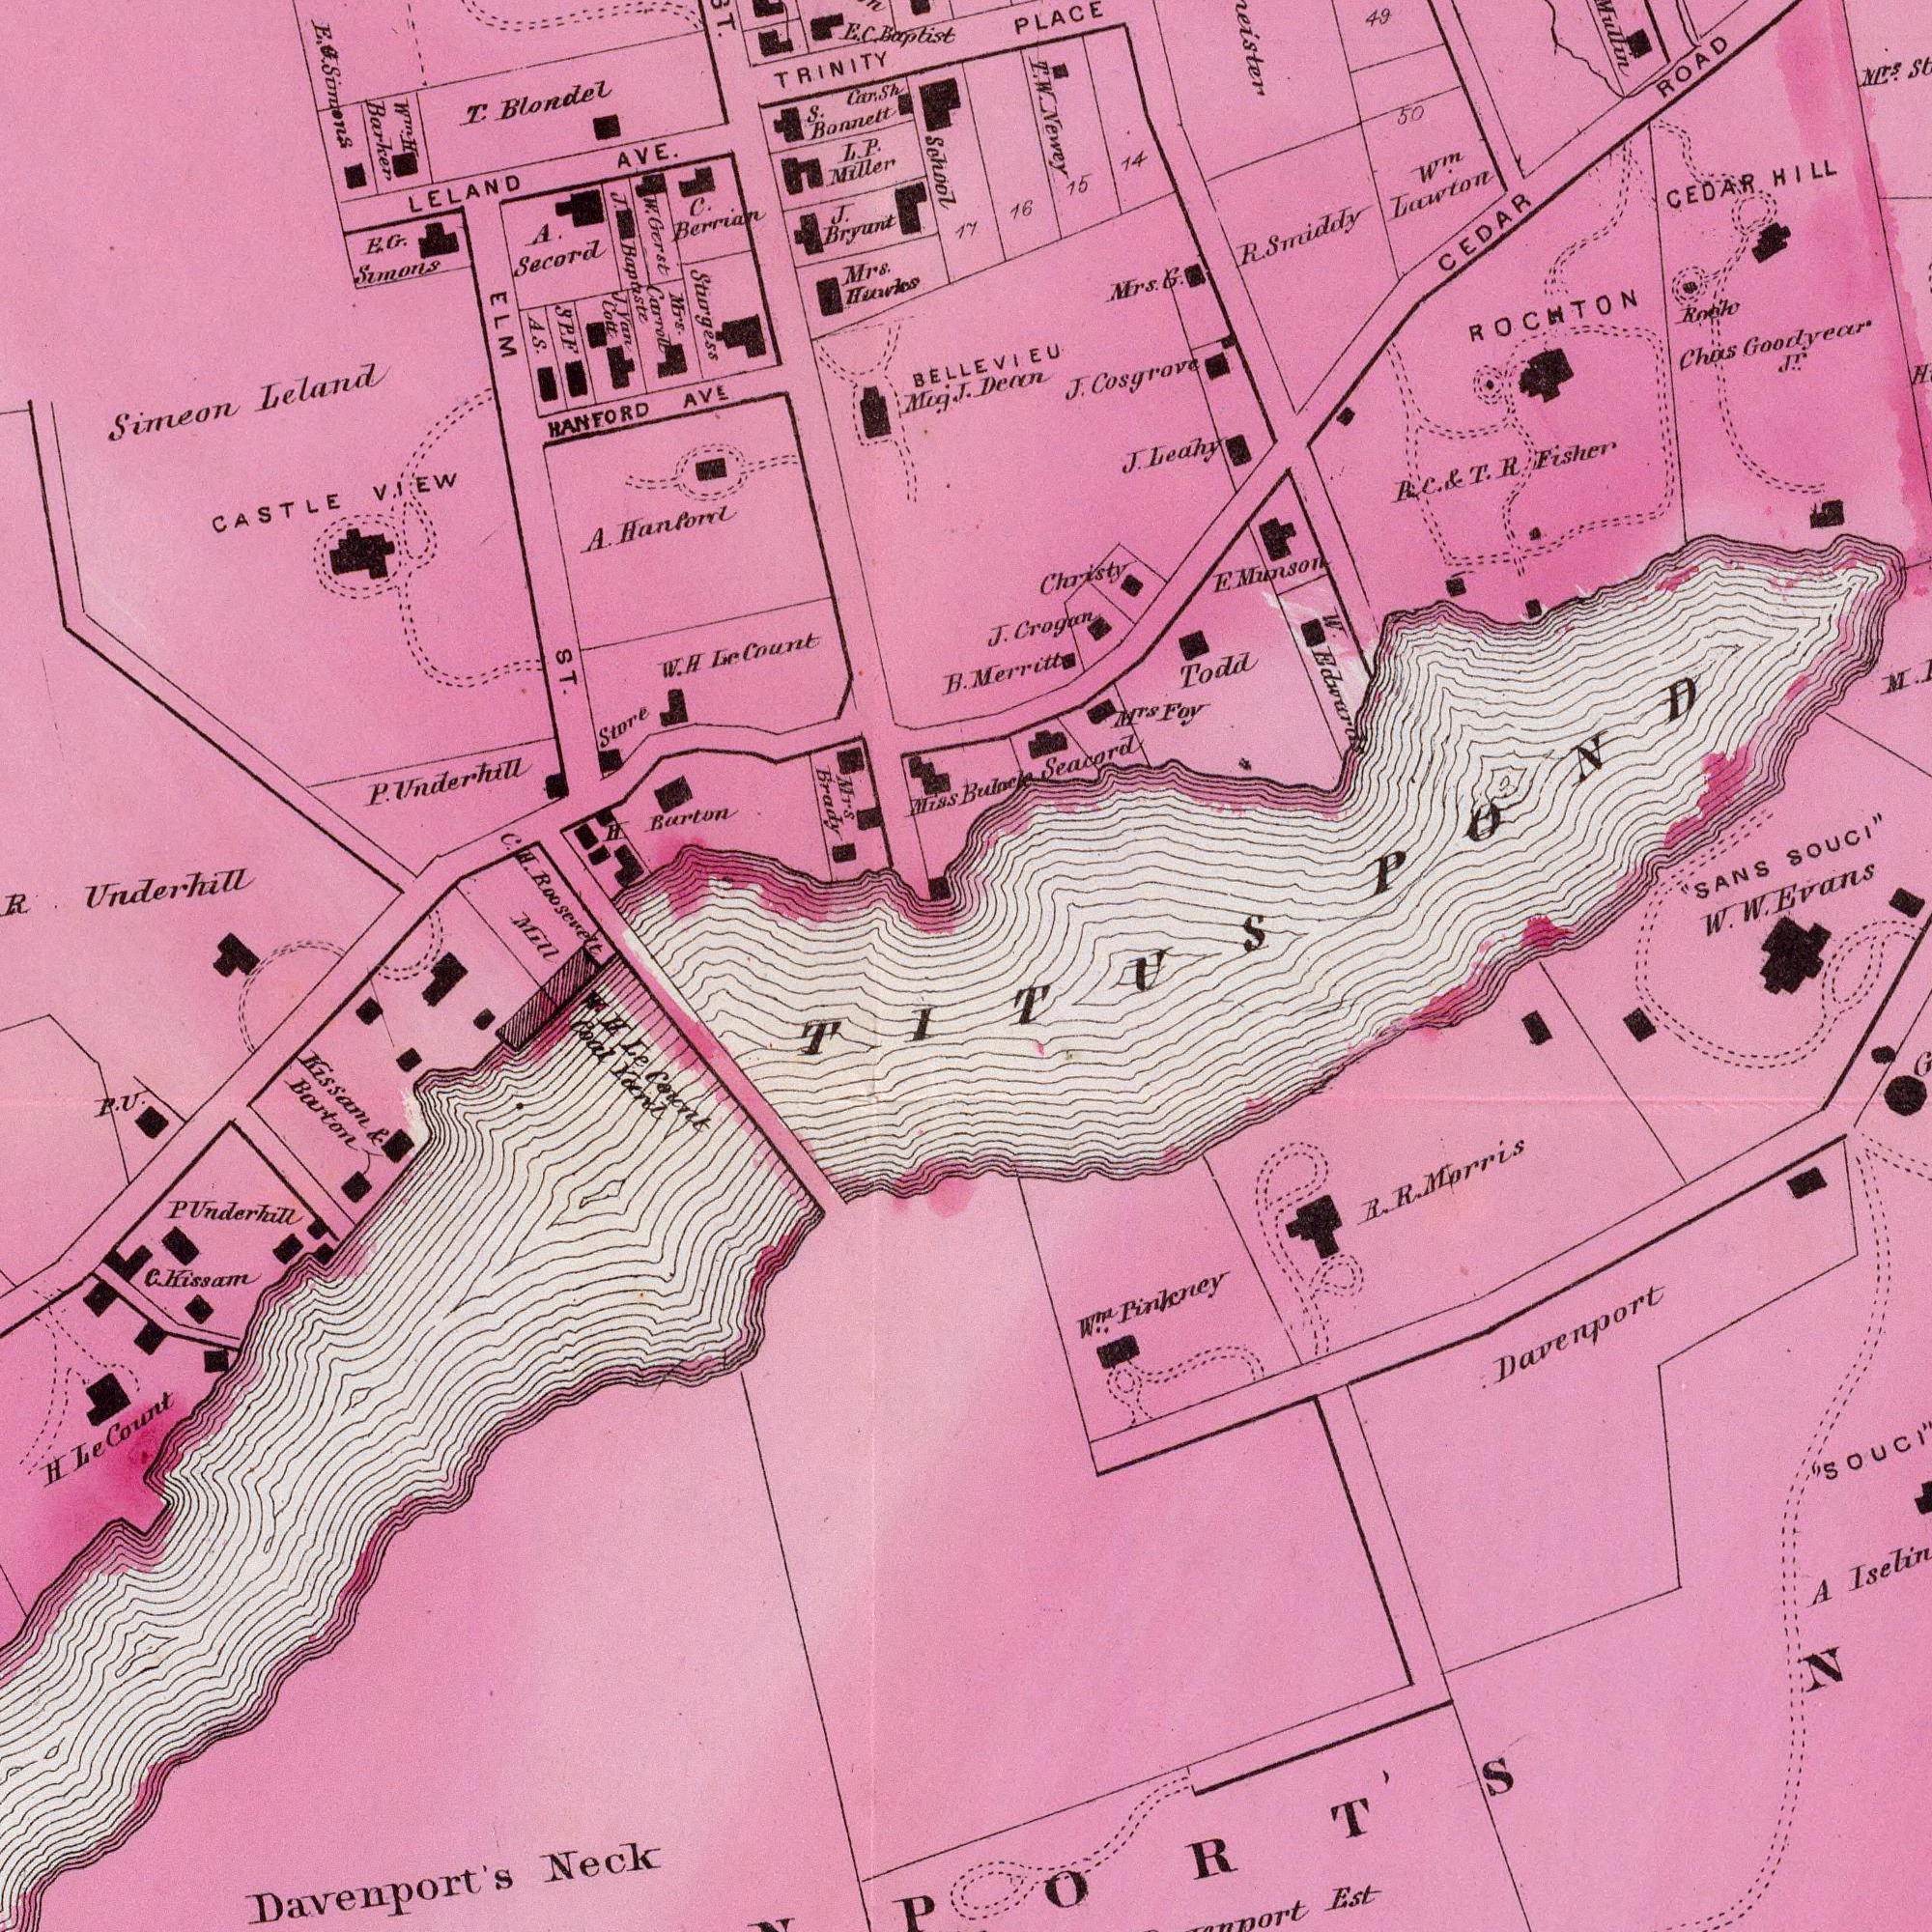What text is shown in the bottom-right quadrant? Davenport Est A R. R. Morris N w.<sup>m</sup>. Pinkney "SOUCI" TITUS What text is visible in the lower-left corner? Davenports's Neck Kissam R. Barton H Le Count W. H. Le Count Coal Yard P Underhill C. Kissam P. U. What text is shown in the top-right quadrant? Bulock Seacord PLACE BELLEVIEU Merritt CEDAR HILL M<sup>rs</sup>. "SANS SOUCI" Chas Goodyear J.<sup>r</sup>. CEDAR ROAD P. C. & T. R Fisher J. Crogan W<sup>m</sup>. Lawton 49 Christy J. Leahy J. Cosgrove Rook M<sup>rs</sup> Foy Todd 50 ROCHTON W. Edwards 16 E Munson R. Smiddy Mrs. G. 15 W. W. Evans 14 T. W. Newey M. POND 17 Dean What text is shown in the top-left quadrant? School W<sup>m</sup>. H Barker LELAND AVE. S. Car. Sh Bonnett CASTLE VIEW HANFORD AVE T. Blondel Mrs Brady A. Secord Mrs. Huwks C. Berrian C. H. Roosevett Mill H. Barton E. G. Simons L. P. Miller E. C. Baptist J. Bryunt Miss Simeon Leland J. Bapaste ELM ST. TRINITY A. Hanford Mrs. Carroll B. R Underhill P. Underhill Stirgess Store E. G. Simons Muj J. W. H Lc Count W. Grest J. Van Cott A. S S P F 